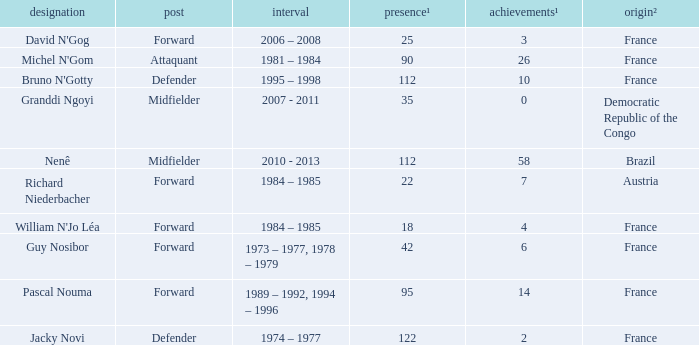Help me parse the entirety of this table. {'header': ['designation', 'post', 'interval', 'presence¹', 'achievements¹', 'origin²'], 'rows': [["David N'Gog", 'Forward', '2006 – 2008', '25', '3', 'France'], ["Michel N'Gom", 'Attaquant', '1981 – 1984', '90', '26', 'France'], ["Bruno N'Gotty", 'Defender', '1995 – 1998', '112', '10', 'France'], ['Granddi Ngoyi', 'Midfielder', '2007 - 2011', '35', '0', 'Democratic Republic of the Congo'], ['Nenê', 'Midfielder', '2010 - 2013', '112', '58', 'Brazil'], ['Richard Niederbacher', 'Forward', '1984 – 1985', '22', '7', 'Austria'], ["William N'Jo Léa", 'Forward', '1984 – 1985', '18', '4', 'France'], ['Guy Nosibor', 'Forward', '1973 – 1977, 1978 – 1979', '42', '6', 'France'], ['Pascal Nouma', 'Forward', '1989 – 1992, 1994 – 1996', '95', '14', 'France'], ['Jacky Novi', 'Defender', '1974 – 1977', '122', '2', 'France']]} How many games had less than 7 goals scored? 1.0. 